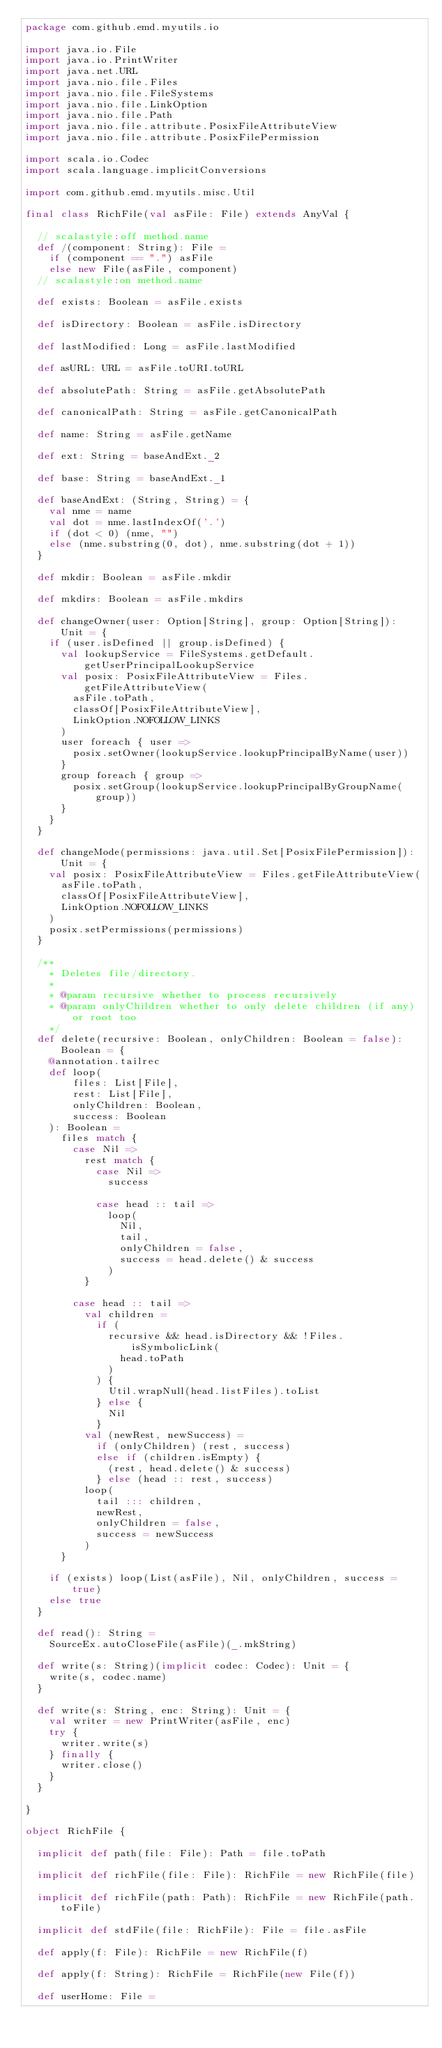Convert code to text. <code><loc_0><loc_0><loc_500><loc_500><_Scala_>package com.github.emd.myutils.io

import java.io.File
import java.io.PrintWriter
import java.net.URL
import java.nio.file.Files
import java.nio.file.FileSystems
import java.nio.file.LinkOption
import java.nio.file.Path
import java.nio.file.attribute.PosixFileAttributeView
import java.nio.file.attribute.PosixFilePermission

import scala.io.Codec
import scala.language.implicitConversions

import com.github.emd.myutils.misc.Util

final class RichFile(val asFile: File) extends AnyVal {

  // scalastyle:off method.name
  def /(component: String): File =
    if (component == ".") asFile
    else new File(asFile, component)
  // scalastyle:on method.name

  def exists: Boolean = asFile.exists

  def isDirectory: Boolean = asFile.isDirectory

  def lastModified: Long = asFile.lastModified

  def asURL: URL = asFile.toURI.toURL

  def absolutePath: String = asFile.getAbsolutePath

  def canonicalPath: String = asFile.getCanonicalPath

  def name: String = asFile.getName

  def ext: String = baseAndExt._2

  def base: String = baseAndExt._1

  def baseAndExt: (String, String) = {
    val nme = name
    val dot = nme.lastIndexOf('.')
    if (dot < 0) (nme, "")
    else (nme.substring(0, dot), nme.substring(dot + 1))
  }

  def mkdir: Boolean = asFile.mkdir

  def mkdirs: Boolean = asFile.mkdirs

  def changeOwner(user: Option[String], group: Option[String]): Unit = {
    if (user.isDefined || group.isDefined) {
      val lookupService = FileSystems.getDefault.getUserPrincipalLookupService
      val posix: PosixFileAttributeView = Files.getFileAttributeView(
        asFile.toPath,
        classOf[PosixFileAttributeView],
        LinkOption.NOFOLLOW_LINKS
      )
      user foreach { user =>
        posix.setOwner(lookupService.lookupPrincipalByName(user))
      }
      group foreach { group =>
        posix.setGroup(lookupService.lookupPrincipalByGroupName(group))
      }
    }
  }

  def changeMode(permissions: java.util.Set[PosixFilePermission]): Unit = {
    val posix: PosixFileAttributeView = Files.getFileAttributeView(
      asFile.toPath,
      classOf[PosixFileAttributeView],
      LinkOption.NOFOLLOW_LINKS
    )
    posix.setPermissions(permissions)
  }

  /**
    * Deletes file/directory.
    *
    * @param recursive whether to process recursively
    * @param onlyChildren whether to only delete children (if any) or root too
    */
  def delete(recursive: Boolean, onlyChildren: Boolean = false): Boolean = {
    @annotation.tailrec
    def loop(
        files: List[File],
        rest: List[File],
        onlyChildren: Boolean,
        success: Boolean
    ): Boolean =
      files match {
        case Nil =>
          rest match {
            case Nil =>
              success

            case head :: tail =>
              loop(
                Nil,
                tail,
                onlyChildren = false,
                success = head.delete() & success
              )
          }

        case head :: tail =>
          val children =
            if (
              recursive && head.isDirectory && !Files.isSymbolicLink(
                head.toPath
              )
            ) {
              Util.wrapNull(head.listFiles).toList
            } else {
              Nil
            }
          val (newRest, newSuccess) =
            if (onlyChildren) (rest, success)
            else if (children.isEmpty) {
              (rest, head.delete() & success)
            } else (head :: rest, success)
          loop(
            tail ::: children,
            newRest,
            onlyChildren = false,
            success = newSuccess
          )
      }

    if (exists) loop(List(asFile), Nil, onlyChildren, success = true)
    else true
  }

  def read(): String =
    SourceEx.autoCloseFile(asFile)(_.mkString)

  def write(s: String)(implicit codec: Codec): Unit = {
    write(s, codec.name)
  }

  def write(s: String, enc: String): Unit = {
    val writer = new PrintWriter(asFile, enc)
    try {
      writer.write(s)
    } finally {
      writer.close()
    }
  }

}

object RichFile {

  implicit def path(file: File): Path = file.toPath

  implicit def richFile(file: File): RichFile = new RichFile(file)

  implicit def richFile(path: Path): RichFile = new RichFile(path.toFile)

  implicit def stdFile(file: RichFile): File = file.asFile

  def apply(f: File): RichFile = new RichFile(f)

  def apply(f: String): RichFile = RichFile(new File(f))

  def userHome: File =</code> 